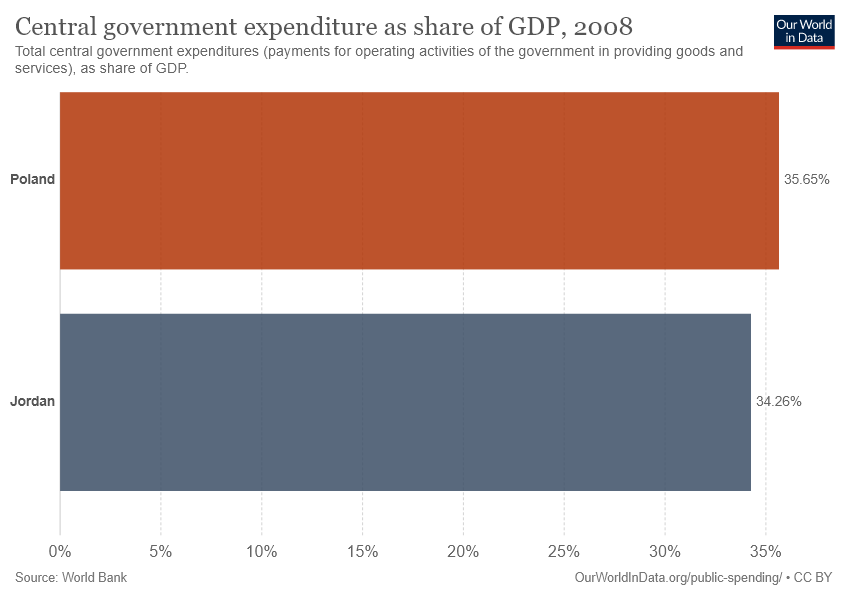What place does the orange bar represent?
 Poland 